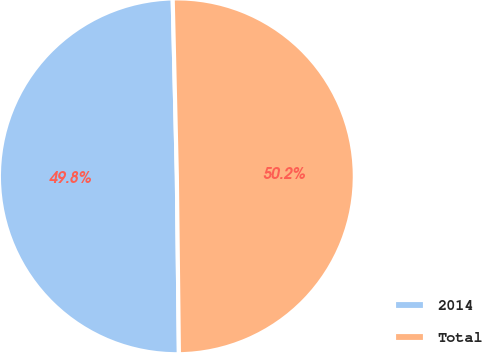Convert chart. <chart><loc_0><loc_0><loc_500><loc_500><pie_chart><fcel>2014<fcel>Total<nl><fcel>49.81%<fcel>50.19%<nl></chart> 